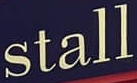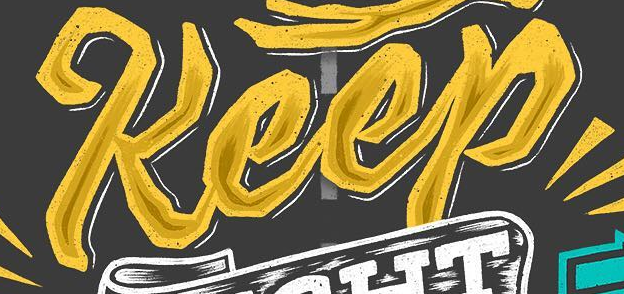Read the text from these images in sequence, separated by a semicolon. stall; Keep 